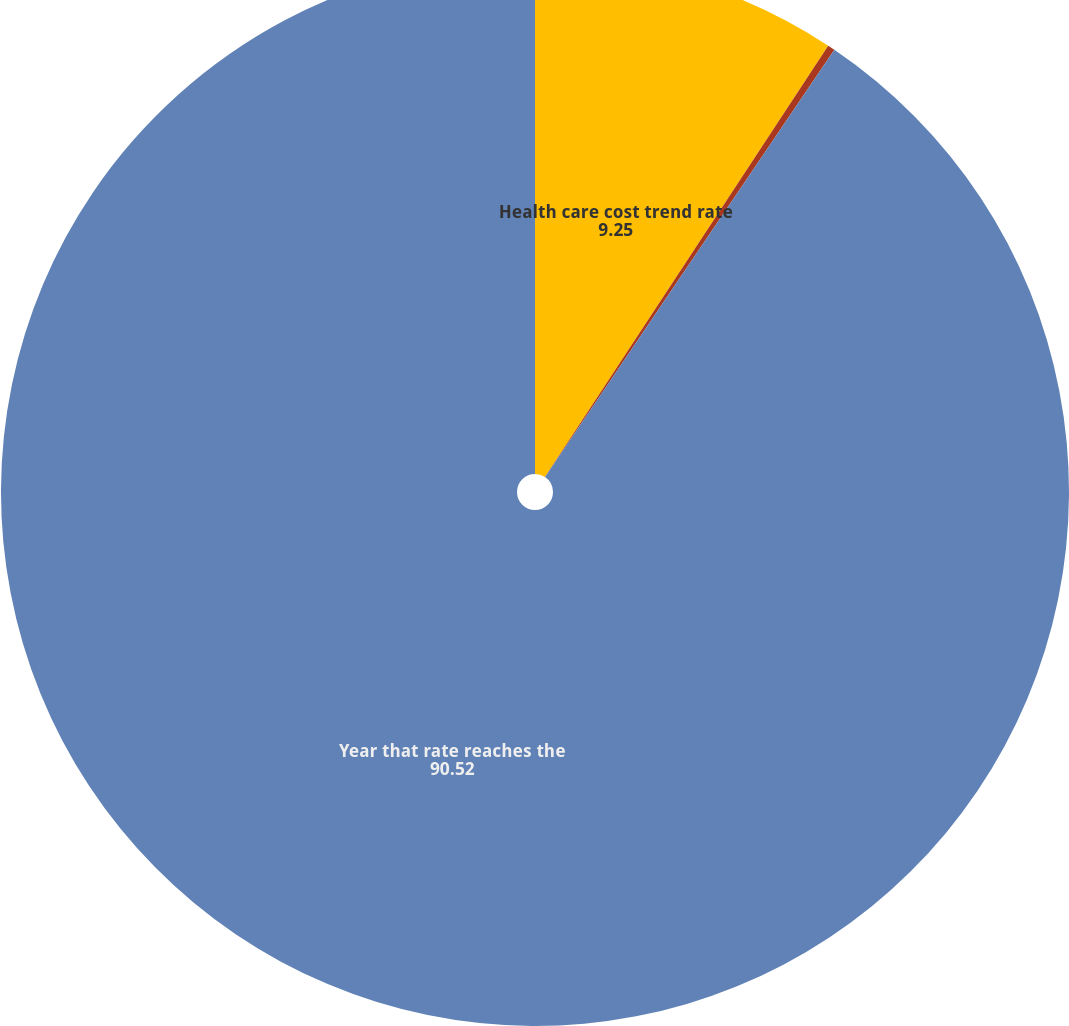Convert chart to OTSL. <chart><loc_0><loc_0><loc_500><loc_500><pie_chart><fcel>Health care cost trend rate<fcel>Rate that the cost trend rate<fcel>Year that rate reaches the<nl><fcel>9.25%<fcel>0.22%<fcel>90.52%<nl></chart> 